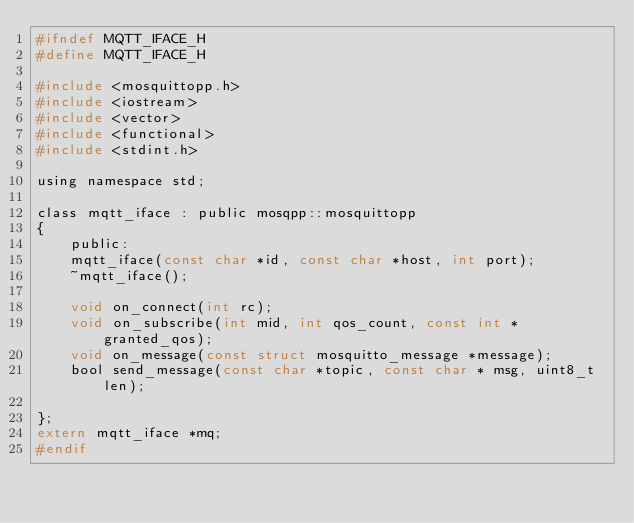Convert code to text. <code><loc_0><loc_0><loc_500><loc_500><_C_>#ifndef MQTT_IFACE_H
#define MQTT_IFACE_H

#include <mosquittopp.h>
#include <iostream>
#include <vector>
#include <functional>
#include <stdint.h>

using namespace std;

class mqtt_iface : public mosqpp::mosquittopp
{
	public:
	mqtt_iface(const char *id, const char *host, int port);
	~mqtt_iface();

	void on_connect(int rc);
	void on_subscribe(int mid, int qos_count, const int *granted_qos);
	void on_message(const struct mosquitto_message *message);
	bool send_message(const char *topic, const char * msg, uint8_t len);

};
extern mqtt_iface *mq;
#endif
</code> 